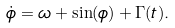<formula> <loc_0><loc_0><loc_500><loc_500>\dot { \phi } = \omega + \sin ( \phi ) + \Gamma ( t ) .</formula> 